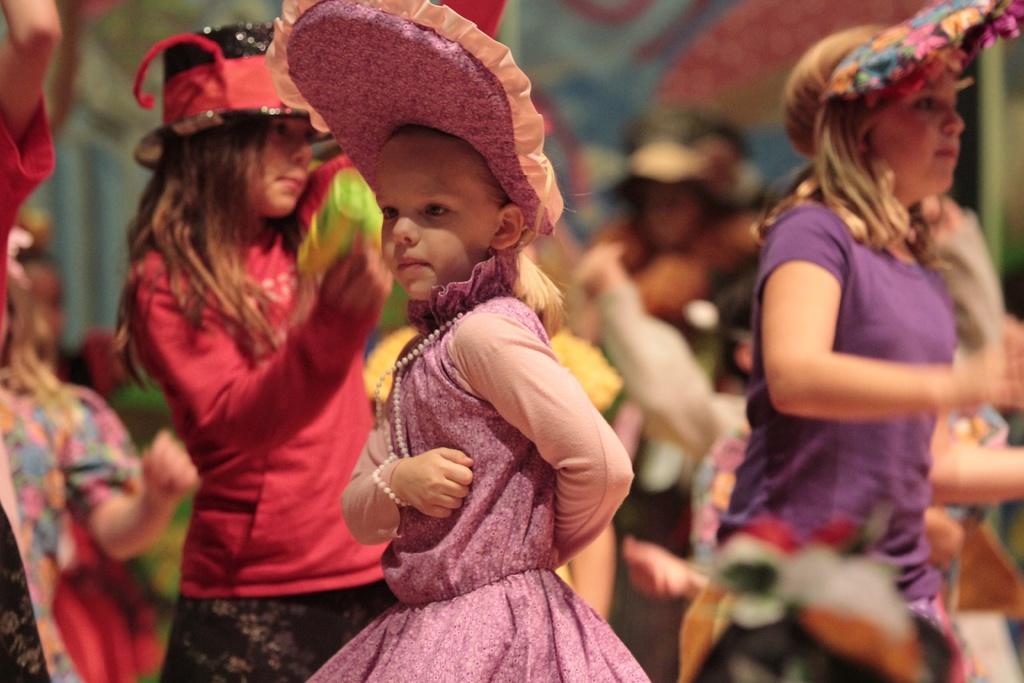Could you give a brief overview of what you see in this image? This picture seems to be clicked inside. In the center we can see the group of children holding some objects and seems to be standing. The background of the image is blurry and there are some objects in the background. 